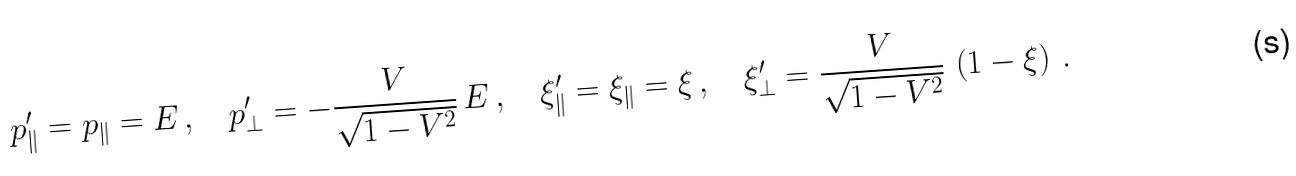Convert formula to latex. <formula><loc_0><loc_0><loc_500><loc_500>p ^ { \prime } _ { \| } = p _ { \| } = E \, , \quad p ^ { \prime } _ { \perp } = - \frac { V } { \sqrt { 1 - V ^ { 2 } } } \, E \, , \quad \xi ^ { \prime } _ { \| } = \xi _ { \| } = \xi \, , \quad \xi ^ { \prime } _ { \perp } = \frac { V } { \sqrt { 1 - V ^ { 2 } } } \, \left ( 1 - \xi \right ) \, .</formula> 